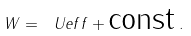Convert formula to latex. <formula><loc_0><loc_0><loc_500><loc_500>W = \ U e f f + \text {const} \, .</formula> 